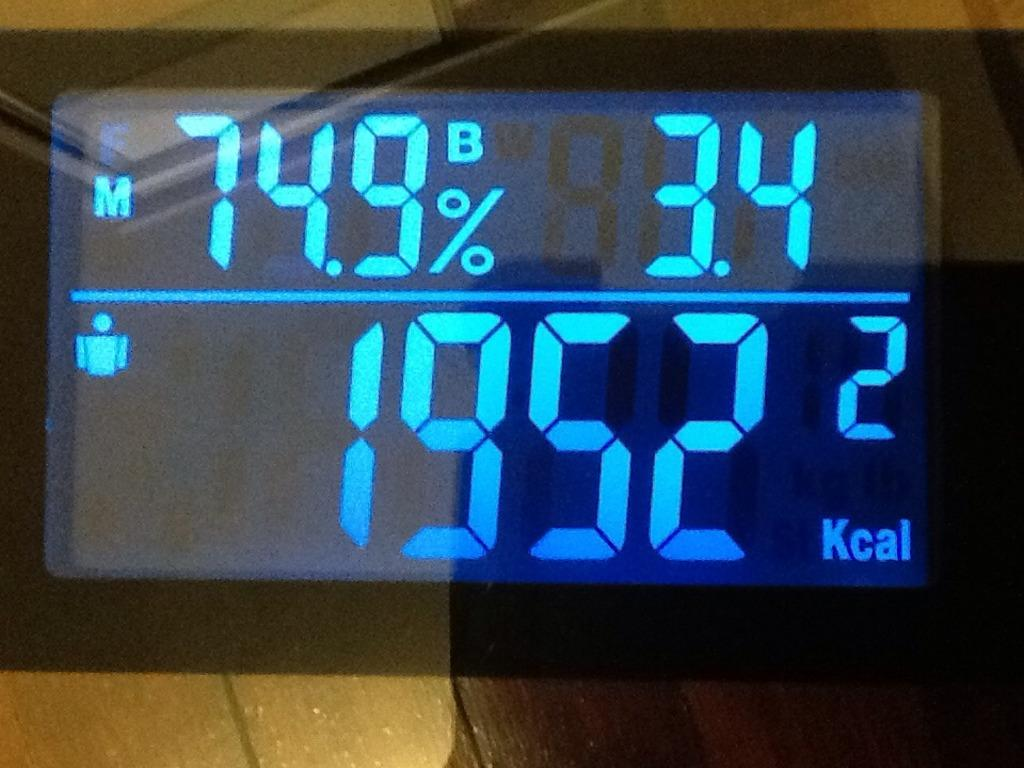<image>
Share a concise interpretation of the image provided. a screen displaying 1952 Kcal in bright blue on a black background 